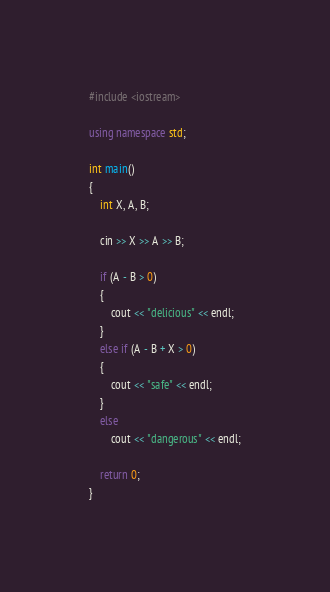Convert code to text. <code><loc_0><loc_0><loc_500><loc_500><_C++_>#include <iostream>

using namespace std;

int main()
{
	int X, A, B;

	cin >> X >> A >> B;

	if (A - B > 0)
	{
		cout << "delicious" << endl;
	}
	else if (A - B + X > 0)
	{
		cout << "safe" << endl;
	}
	else
		cout << "dangerous" << endl;

	return 0;
}
</code> 